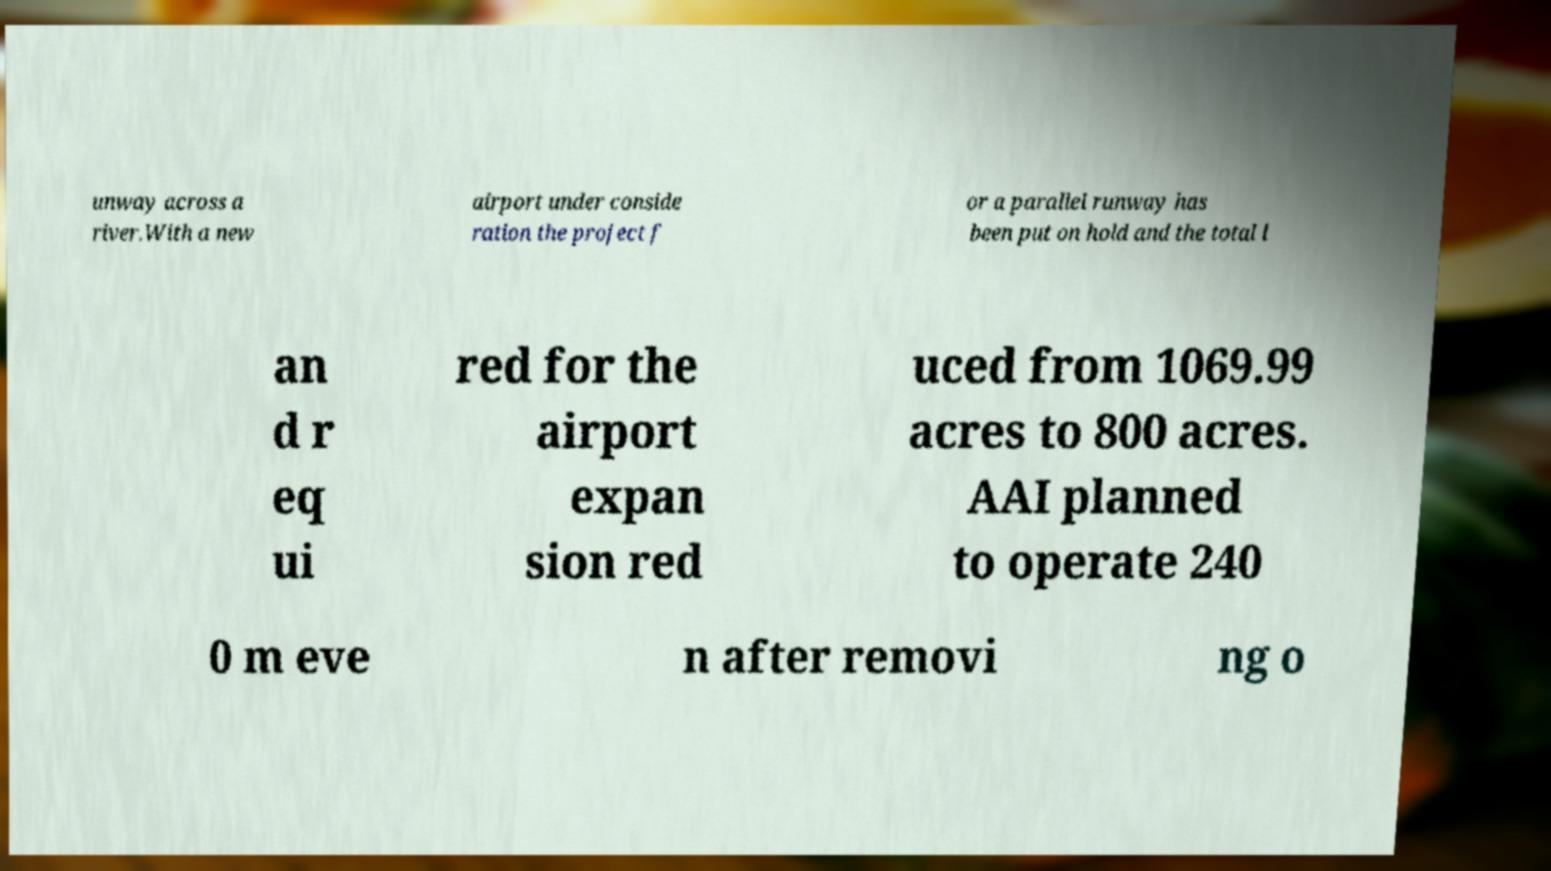For documentation purposes, I need the text within this image transcribed. Could you provide that? unway across a river.With a new airport under conside ration the project f or a parallel runway has been put on hold and the total l an d r eq ui red for the airport expan sion red uced from 1069.99 acres to 800 acres. AAI planned to operate 240 0 m eve n after removi ng o 